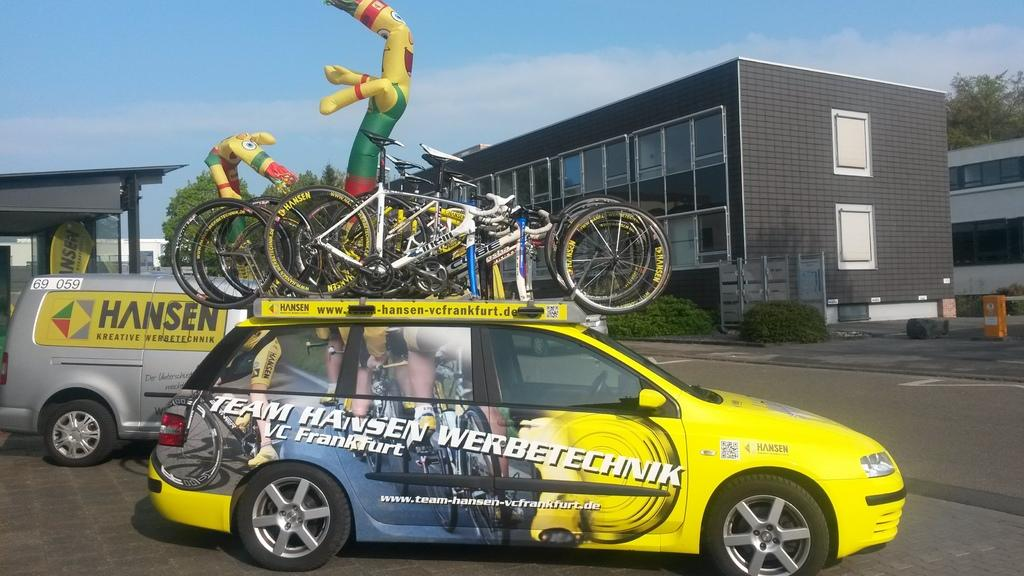<image>
Present a compact description of the photo's key features. A yellow car has several bikes on top, belonging to Team Hansen Werbetechnik. 